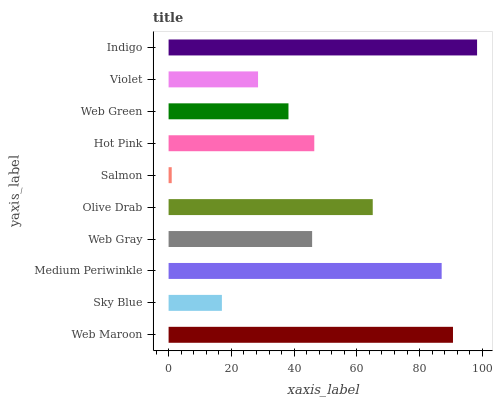Is Salmon the minimum?
Answer yes or no. Yes. Is Indigo the maximum?
Answer yes or no. Yes. Is Sky Blue the minimum?
Answer yes or no. No. Is Sky Blue the maximum?
Answer yes or no. No. Is Web Maroon greater than Sky Blue?
Answer yes or no. Yes. Is Sky Blue less than Web Maroon?
Answer yes or no. Yes. Is Sky Blue greater than Web Maroon?
Answer yes or no. No. Is Web Maroon less than Sky Blue?
Answer yes or no. No. Is Hot Pink the high median?
Answer yes or no. Yes. Is Web Gray the low median?
Answer yes or no. Yes. Is Violet the high median?
Answer yes or no. No. Is Web Maroon the low median?
Answer yes or no. No. 